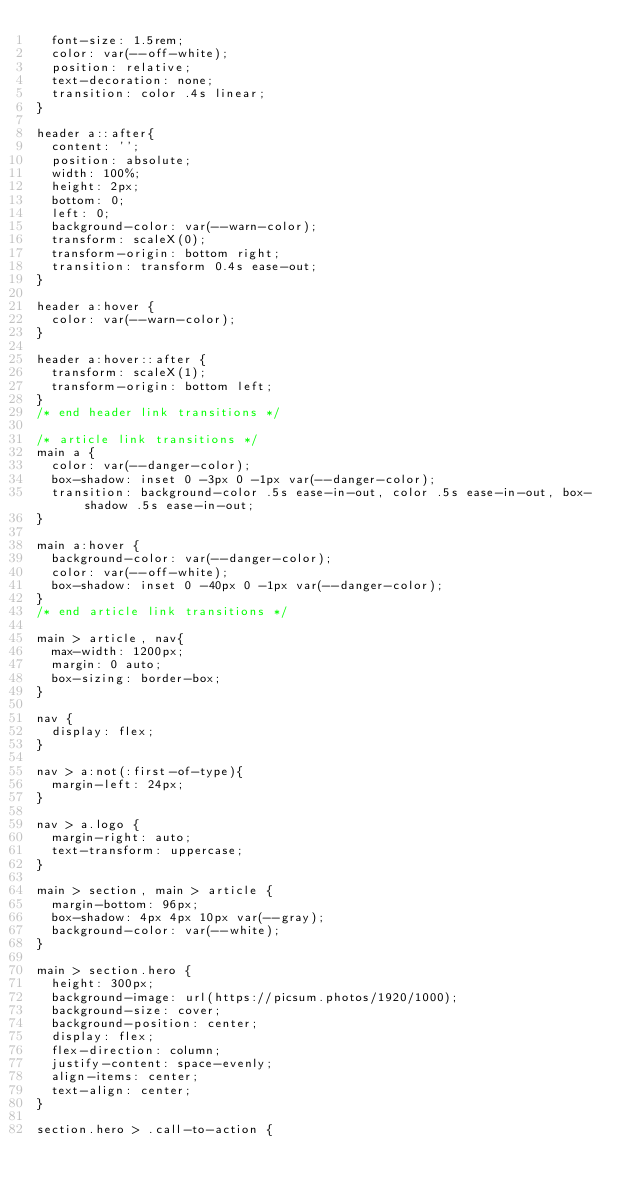<code> <loc_0><loc_0><loc_500><loc_500><_CSS_>  font-size: 1.5rem;
  color: var(--off-white);
  position: relative;
  text-decoration: none;
  transition: color .4s linear;
}

header a::after{
  content: '';
  position: absolute;
  width: 100%;
  height: 2px;
  bottom: 0;
  left: 0;
  background-color: var(--warn-color);
  transform: scaleX(0);
  transform-origin: bottom right;
  transition: transform 0.4s ease-out;
}

header a:hover {
  color: var(--warn-color);
}

header a:hover::after {
  transform: scaleX(1);
  transform-origin: bottom left;
} 
/* end header link transitions */

/* article link transitions */
main a {
  color: var(--danger-color);
  box-shadow: inset 0 -3px 0 -1px var(--danger-color);
  transition: background-color .5s ease-in-out, color .5s ease-in-out, box-shadow .5s ease-in-out;
}

main a:hover {
  background-color: var(--danger-color);
  color: var(--off-white);
  box-shadow: inset 0 -40px 0 -1px var(--danger-color);
}
/* end article link transitions */

main > article, nav{
  max-width: 1200px;
  margin: 0 auto;
  box-sizing: border-box;
}

nav {
  display: flex;
}

nav > a:not(:first-of-type){
  margin-left: 24px;
}

nav > a.logo {
  margin-right: auto;
  text-transform: uppercase;
}

main > section, main > article {
  margin-bottom: 96px;
  box-shadow: 4px 4px 10px var(--gray);
  background-color: var(--white);
}

main > section.hero {
  height: 300px;
  background-image: url(https://picsum.photos/1920/1000);
  background-size: cover;
  background-position: center;
  display: flex;
  flex-direction: column;
  justify-content: space-evenly;
  align-items: center;
  text-align: center;
}

section.hero > .call-to-action {</code> 